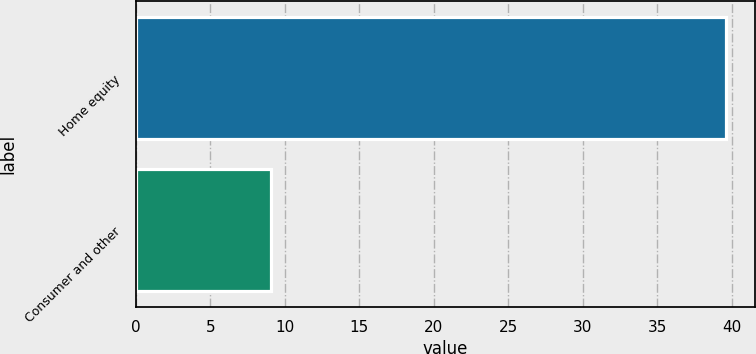<chart> <loc_0><loc_0><loc_500><loc_500><bar_chart><fcel>Home equity<fcel>Consumer and other<nl><fcel>39.6<fcel>9.1<nl></chart> 